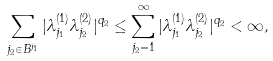Convert formula to latex. <formula><loc_0><loc_0><loc_500><loc_500>\sum _ { j _ { 2 } \in B ^ { j _ { 1 } } } | \lambda ^ { ( 1 ) } _ { j _ { 1 } } \lambda ^ { ( 2 ) } _ { j _ { 2 } } | ^ { q _ { 2 } } \leq \sum _ { j _ { 2 } = 1 } ^ { \infty } | \lambda ^ { ( 1 ) } _ { j _ { 1 } } \lambda ^ { ( 2 ) } _ { j _ { 2 } } | ^ { q _ { 2 } } < \infty ,</formula> 